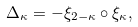Convert formula to latex. <formula><loc_0><loc_0><loc_500><loc_500>\Delta _ { \kappa } = - \xi _ { 2 - \kappa } \circ \xi _ { \kappa } ,</formula> 